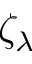<formula> <loc_0><loc_0><loc_500><loc_500>\zeta _ { \lambda }</formula> 